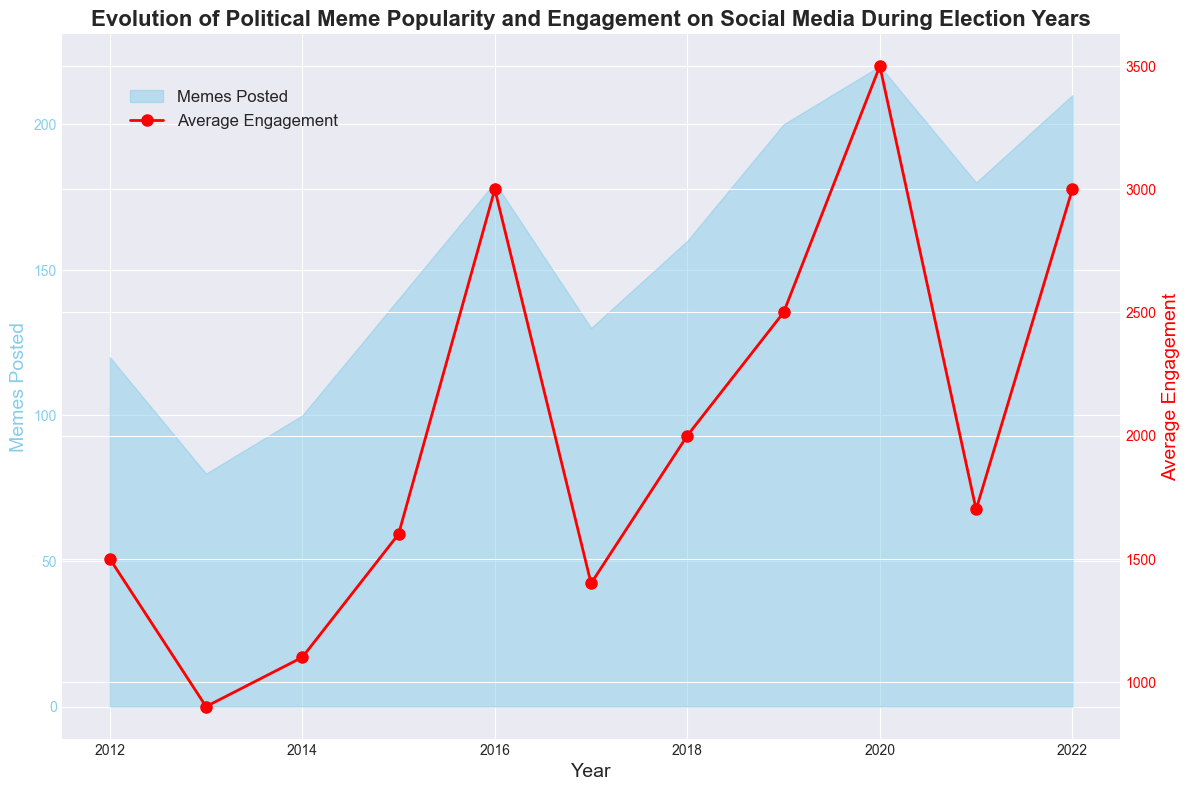What's the highest number of memes posted in a single year? By looking at the area chart for years and observing the peaks in the 'Memes Posted' region, we find that the highest value is in 2020.
Answer: 220 Did the average engagement peak in the same year as the highest number of memes posted? Comparing the peaks on the lines for average engagement and the area under the curve for memes posted, both peak in the year 2020.
Answer: Yes How many memes were posted in the year after the highest engagement year? The highest engagement year is 2020. The year after is 2021. The number of memes posted in 2021 is 180.
Answer: 180 Which year saw the lowest average engagement and what was the value? The red line representing average engagement is at its minimum in the year 2013, with a value of 900.
Answer: 2013 with 900 How did the number of memes posted in 2016 compare to 2015? Observing the area chart, in 2015, the memes posted are 140, and in 2016, it increases to 180. Thus, 2016 saw 40 more memes posted than 2015.
Answer: 40 more In which years did average engagement decrease compared to the previous year? By observing the red line, average engagement decreased in 2013 (from 1500 to 900), 2017 (from 3000 to 1400), and 2021 (from 3500 to 1700).
Answer: 2013, 2017, 2021 What was the difference in average engagement between 2012 and 2022? From the chart, average engagement in 2012 is 1500 and in 2022 is 3000. The difference is 3000 - 1500 = 1500.
Answer: 1500 In which year did the number of memes posted experience the biggest increase compared to the previous year? By observing the differences in the height of the area chart, the largest increase occurred between 2018 (160) and 2019 (200), an increase of 40.
Answer: 2019 What is the average number of memes posted in the election years (2012, 2016, 2020)? The memes posted in election years are 120 (2012), 180 (2016), and 220 (2020). The average is (120 + 180 + 220) / 3 = 173.33.
Answer: 173.33 What trend can be observed in average engagement during election years based on the chart? Observing the red line in election years (2012, 2016, 2020), engagement significantly increases during these years, specifically 1500 in 2012, 3000 in 2016, and 3500 in 2020, indicating higher political engagement.
Answer: Higher engagement in election years 